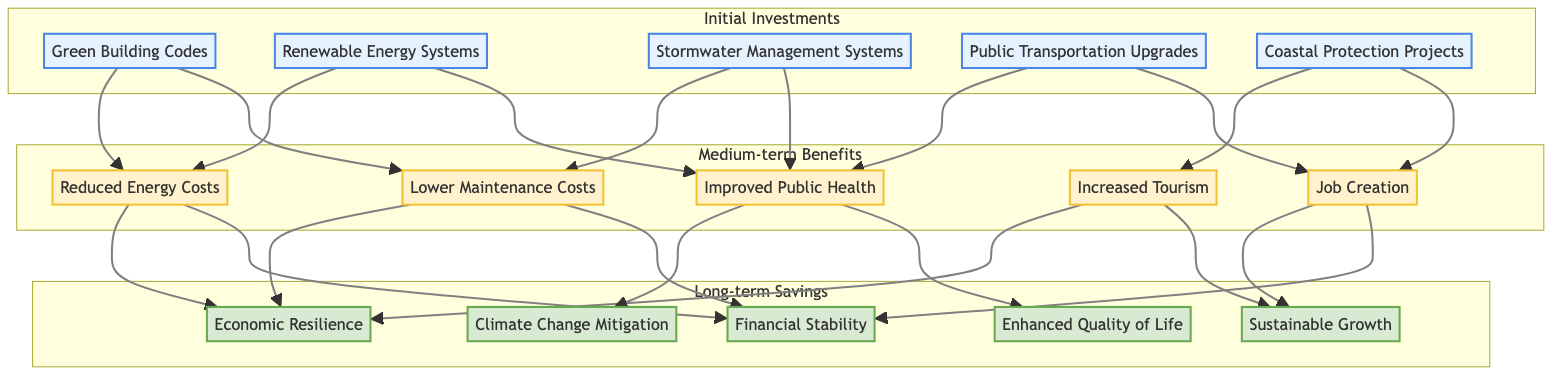What are the five nodes categorized under Initial Investments? The diagram shows five nodes in the Initial Investments category, which are Green Building Codes, Renewable Energy Systems, Stormwater Management Systems, Public Transportation Upgrades, and Coastal Protection Projects.
Answer: Green Building Codes, Renewable Energy Systems, Stormwater Management Systems, Public Transportation Upgrades, Coastal Protection Projects How many nodes are in the Long-term Savings section? There are five nodes listed in the Long-term Savings section of the diagram: Economic Resilience, Sustainable Growth, Climate Change Mitigation, Enhanced Quality of Life, and Financial Stability.
Answer: Five Which Medium-term Benefit is connected to the Stormwater Management Systems? The Stormwater Management Systems node connects to Lower Maintenance Costs and Improved Public Health nodes in the Medium-term Benefits section of the diagram.
Answer: Lower Maintenance Costs, Improved Public Health Which Initial Investment leads to Increased Tourism in Medium-term Benefits? The Coastal Protection Projects node in the Initial Investments section leads to the Increased Tourism node in the Medium-term Benefits, indicating its impact on visitor numbers.
Answer: Coastal Protection Projects If an investment is made in Renewable Energy Systems, what are the two subsequent benefits realized? Investing in Renewable Energy Systems results in Reduced Energy Costs and Improved Public Health, as portrayed in the flows from the Renewable Energy Systems node to these Medium-term Benefits.
Answer: Reduced Energy Costs, Improved Public Health Which Long-term Savings are achieved through Reduced Energy Costs? The Reduced Energy Costs from the Medium-term Benefits connect to Economic Resilience and Financial Stability in the Long-term Savings, suggesting that energy savings contribute to these factors.
Answer: Economic Resilience, Financial Stability What is the main connection between Job Creation and Long-term Savings? Job Creation links to Sustainable Growth and Financial Stability in Long-term Savings, indicating that employment opportunities drive these beneficial outcomes for the city.
Answer: Sustainable Growth, Financial Stability Which two nodes provide a link between Improved Public Health and Long-term Savings? The Improved Public Health node connects to Climate Change Mitigation and Enhanced Quality of Life, thus linking health improvements to positive long-term savings outcomes.
Answer: Climate Change Mitigation, Enhanced Quality of Life 